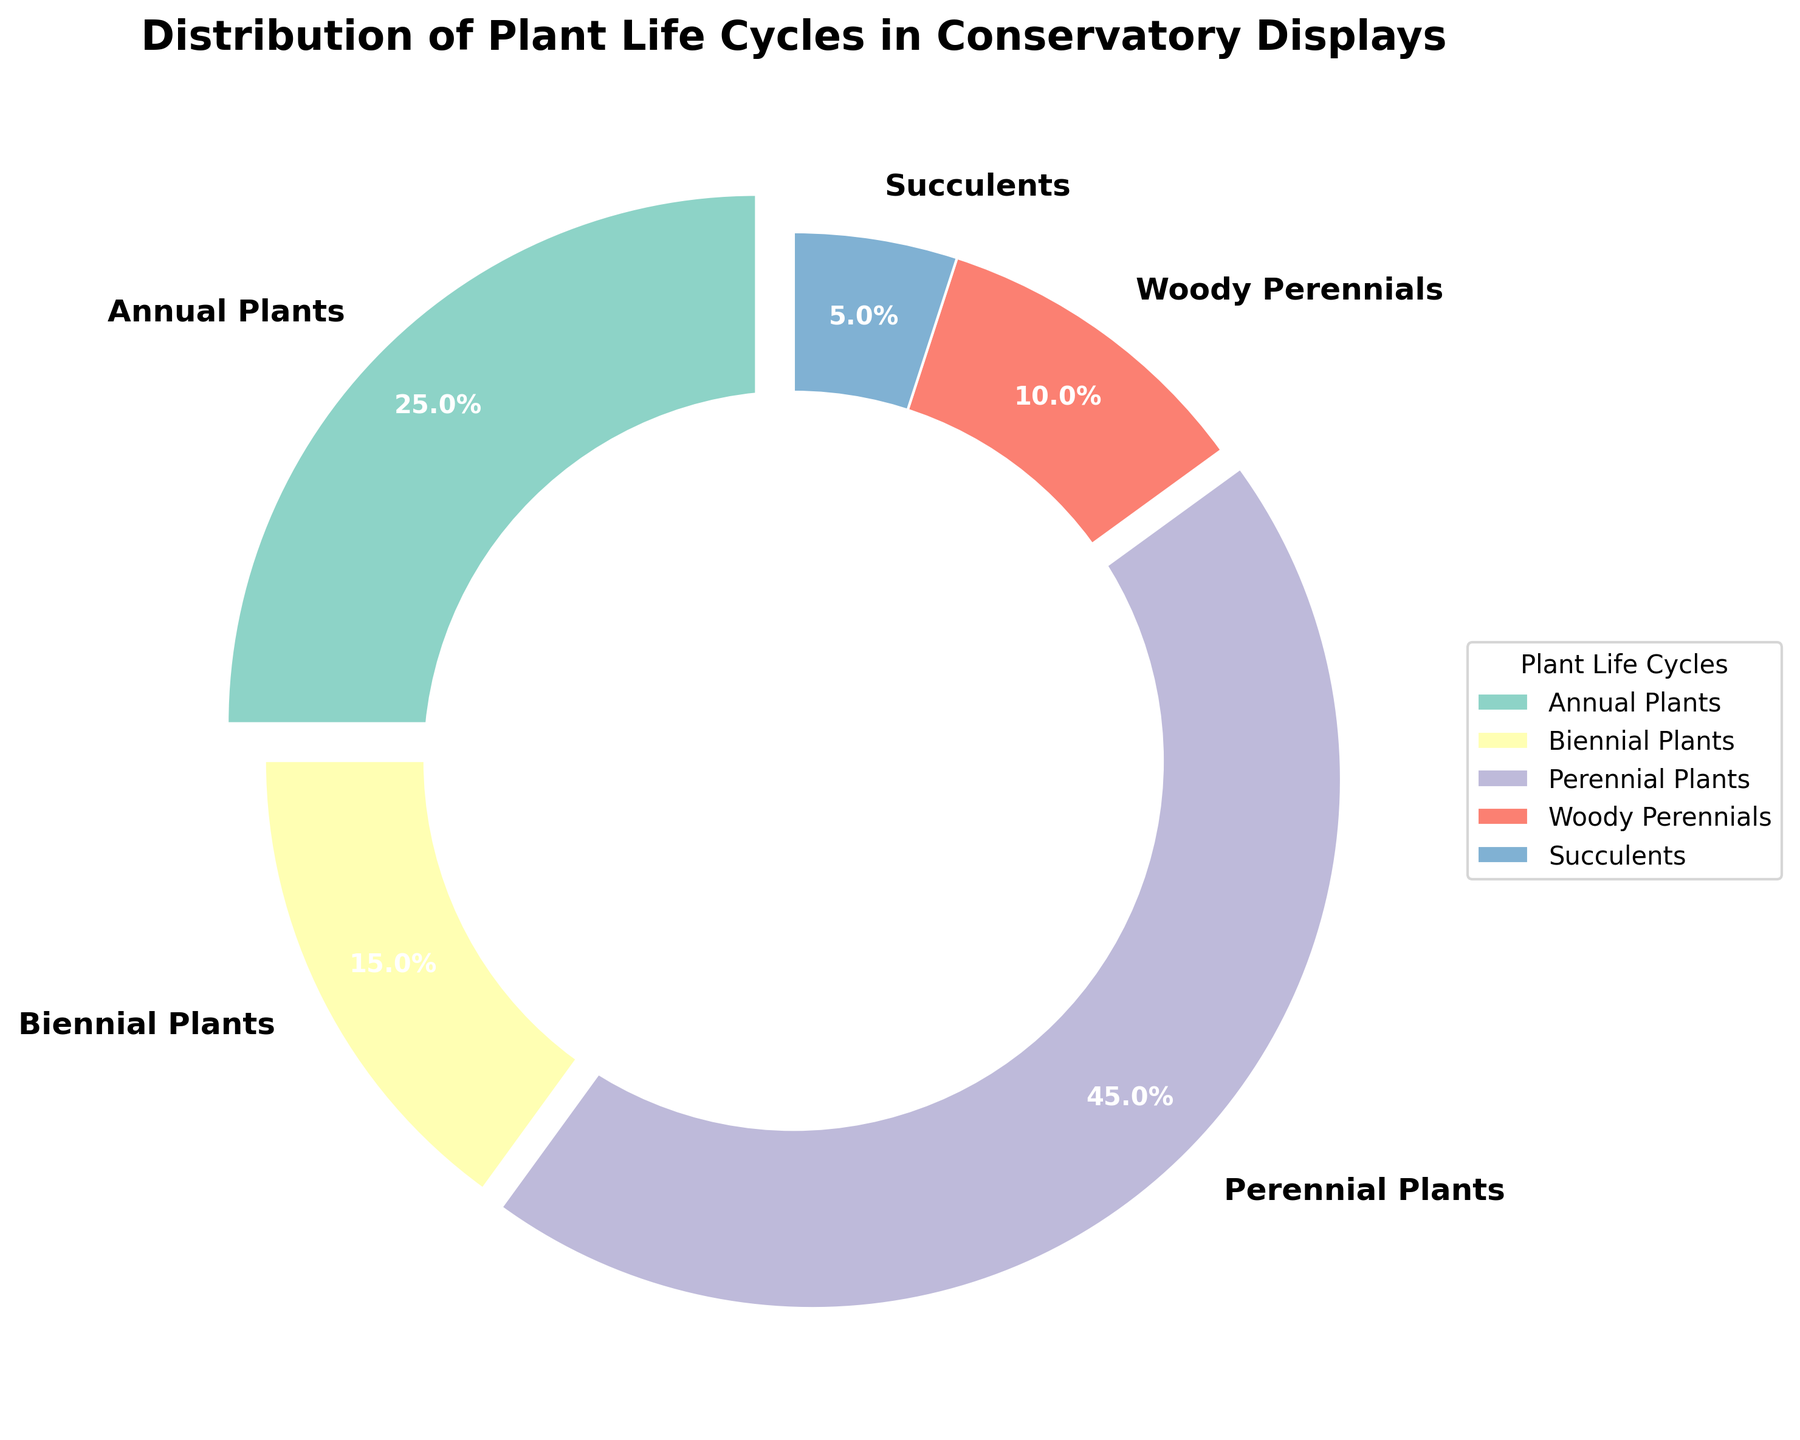What percentage of the displayed plants are annual? The pie chart shows a slice labeled "Annual Plants," and the corresponding percentage is listed. Find the label "Annual Plants" and read the percentage given next to it.
Answer: 25% Between biennials and succulents, which type of plant has a higher percentage in the conservatory? Locate the slices labeled "Biennial Plants" and "Succulents." Compare the percentages. Biennials are 15%, and succulents are 5%. 15% is greater than 5%.
Answer: Biennials What is the combined percentage of biennial and woody perennial plants? Find the slices labeled "Biennial Plants" and "Woody Perennials" and add their percentages together. Biennial Plants are 15% and Woody Perennials are 10%. 15% + 10% = 25%.
Answer: 25% How much larger in percentage are perennials compared to succulents? Locate the slices labeled "Perennial Plants" and "Succulents." Perennial Plants are 45%, and Succulents are 5%. Subtract the percentage of succulents from the percentage of perennials: 45% - 5% = 40%.
Answer: 40% What are the colors representing annual and biennial plants? Identify the colors of the slices corresponding to the labels "Annual Plants" and "Biennial Plants." Annual Plants is represented by a specific color and Biennial Plants by another.
Answer: Green (Annual) and Yellow (Biennial) Which plant life cycle category occupies the smallest slice of the pie chart? Observe the pie chart slices and identify the smallest one by comparing their sizes visually. The smallest slice is labeled "Succulents."
Answer: Succulents If you were to create a new category combining biennial and succulent plants, what would its percentage be and how would it rank in size compared to other categories? Add the percentages of "Biennial Plants" and "Succulents": 15% + 5% = 20%. Compare 20% with the other categories seen in the chart (25%, 45%, 10%). It would rank between annuals (25%) and woody perennials (10%).
Answer: 20%, third largest What fraction of the pie chart do woody perennials and annual plants together occupy? Find the slices labeled "Woody Perennials" and "Annual Plants" and add their percentages together: 10% + 25% = 35%. This is equivalent to the fraction 35/100, which simplifies to 7/20.
Answer: 7/20 